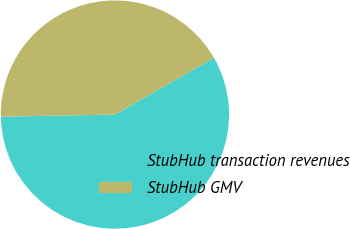Convert chart to OTSL. <chart><loc_0><loc_0><loc_500><loc_500><pie_chart><fcel>StubHub transaction revenues<fcel>StubHub GMV<nl><fcel>58.0%<fcel>42.0%<nl></chart> 